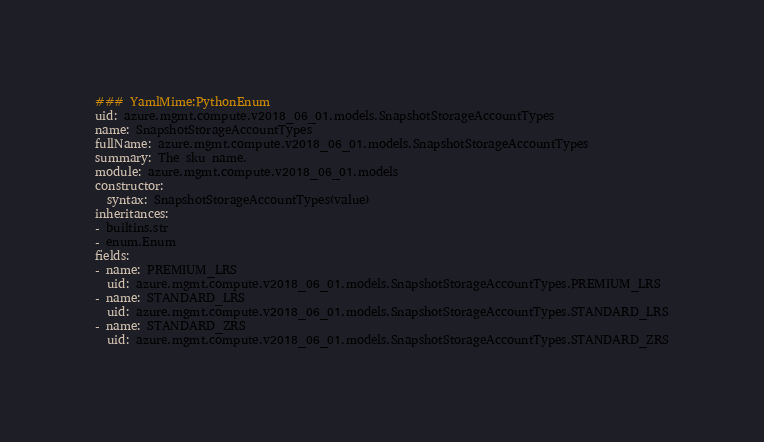Convert code to text. <code><loc_0><loc_0><loc_500><loc_500><_YAML_>### YamlMime:PythonEnum
uid: azure.mgmt.compute.v2018_06_01.models.SnapshotStorageAccountTypes
name: SnapshotStorageAccountTypes
fullName: azure.mgmt.compute.v2018_06_01.models.SnapshotStorageAccountTypes
summary: The sku name.
module: azure.mgmt.compute.v2018_06_01.models
constructor:
  syntax: SnapshotStorageAccountTypes(value)
inheritances:
- builtins.str
- enum.Enum
fields:
- name: PREMIUM_LRS
  uid: azure.mgmt.compute.v2018_06_01.models.SnapshotStorageAccountTypes.PREMIUM_LRS
- name: STANDARD_LRS
  uid: azure.mgmt.compute.v2018_06_01.models.SnapshotStorageAccountTypes.STANDARD_LRS
- name: STANDARD_ZRS
  uid: azure.mgmt.compute.v2018_06_01.models.SnapshotStorageAccountTypes.STANDARD_ZRS
</code> 